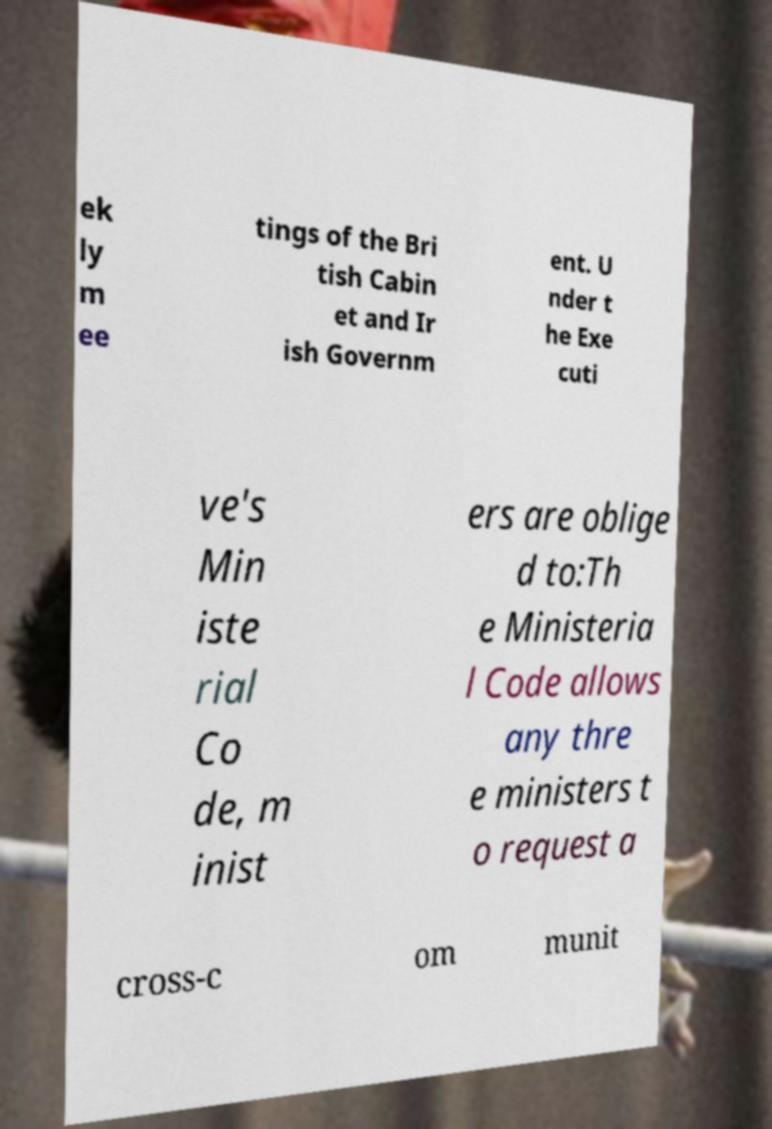Can you accurately transcribe the text from the provided image for me? ek ly m ee tings of the Bri tish Cabin et and Ir ish Governm ent. U nder t he Exe cuti ve's Min iste rial Co de, m inist ers are oblige d to:Th e Ministeria l Code allows any thre e ministers t o request a cross-c om munit 